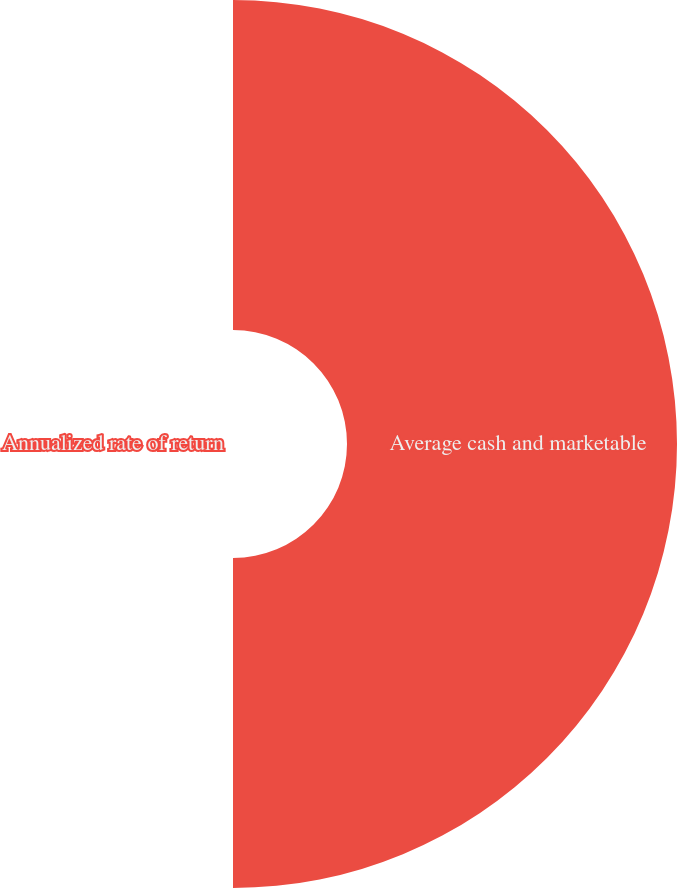Convert chart to OTSL. <chart><loc_0><loc_0><loc_500><loc_500><pie_chart><fcel>Average cash and marketable<fcel>Annualized rate of return<nl><fcel>100.0%<fcel>0.0%<nl></chart> 